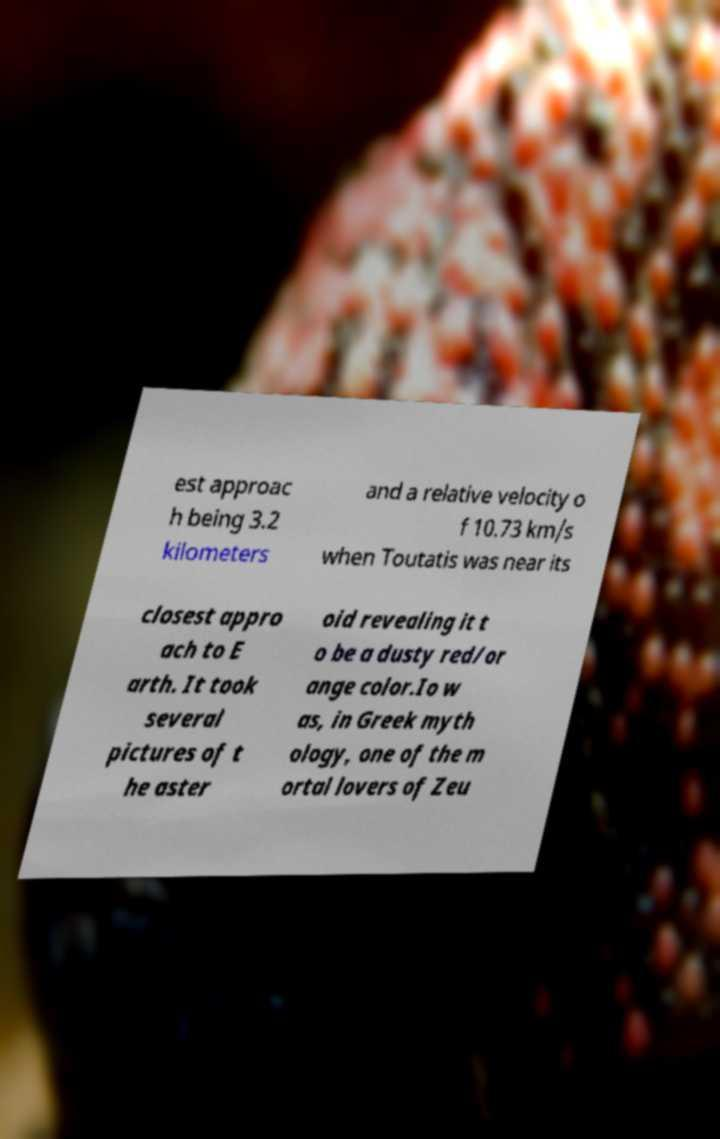There's text embedded in this image that I need extracted. Can you transcribe it verbatim? est approac h being 3.2 kilometers and a relative velocity o f 10.73 km/s when Toutatis was near its closest appro ach to E arth. It took several pictures of t he aster oid revealing it t o be a dusty red/or ange color.Io w as, in Greek myth ology, one of the m ortal lovers of Zeu 